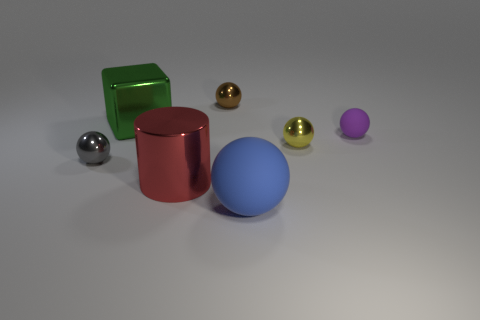Subtract all green balls. Subtract all brown cylinders. How many balls are left? 5 Add 2 small yellow things. How many objects exist? 9 Subtract all balls. How many objects are left? 2 Subtract all tiny yellow balls. Subtract all tiny cyan rubber blocks. How many objects are left? 6 Add 4 yellow objects. How many yellow objects are left? 5 Add 6 small gray balls. How many small gray balls exist? 7 Subtract 0 red cubes. How many objects are left? 7 